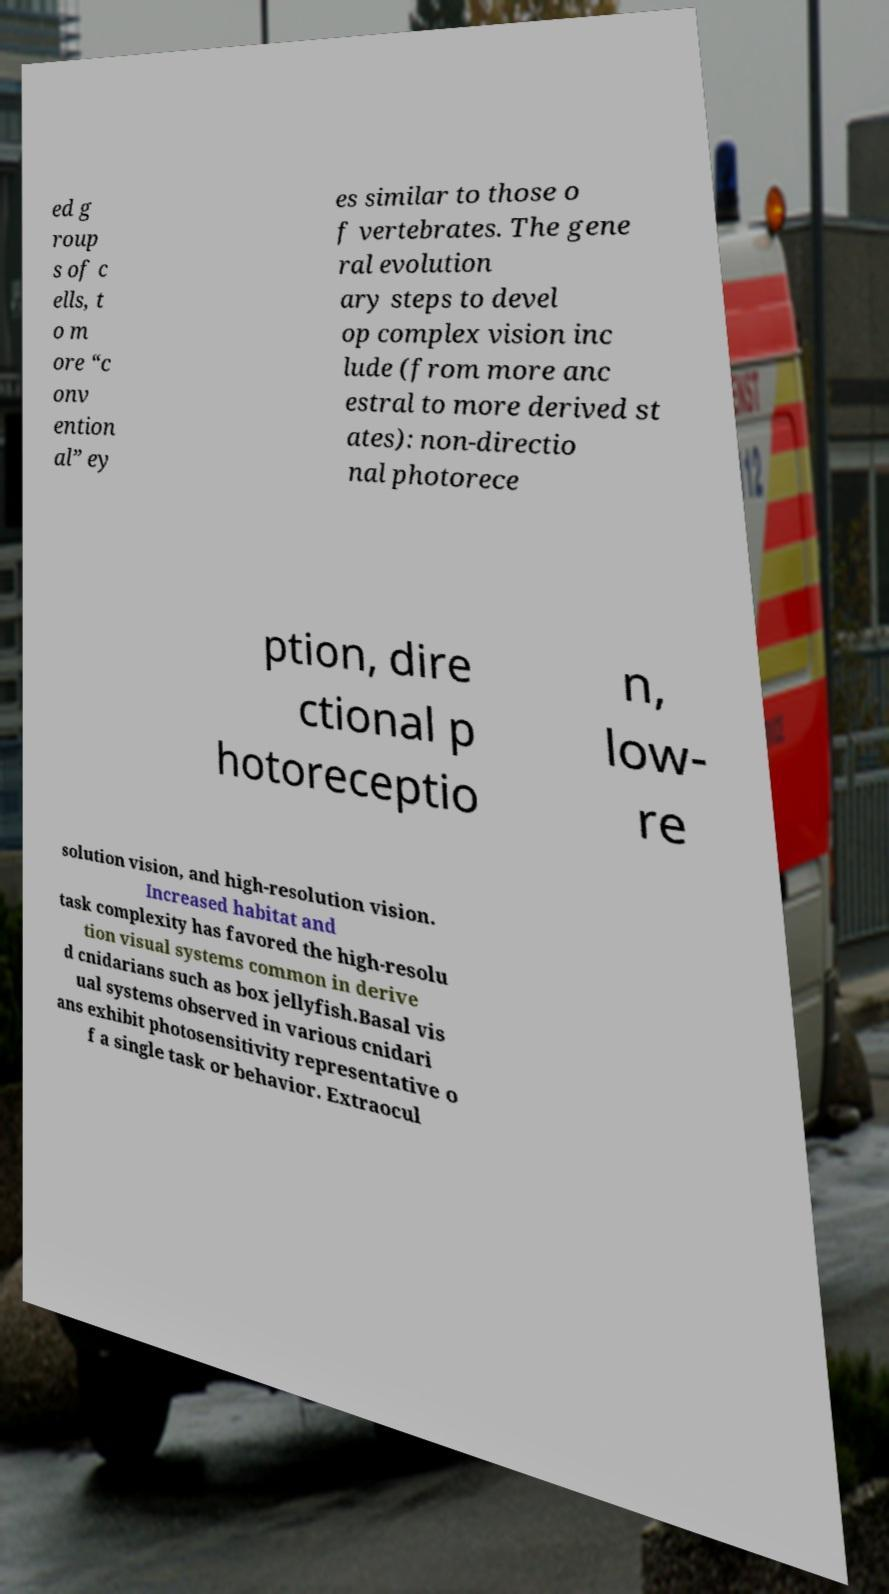Can you read and provide the text displayed in the image?This photo seems to have some interesting text. Can you extract and type it out for me? ed g roup s of c ells, t o m ore “c onv ention al” ey es similar to those o f vertebrates. The gene ral evolution ary steps to devel op complex vision inc lude (from more anc estral to more derived st ates): non-directio nal photorece ption, dire ctional p hotoreceptio n, low- re solution vision, and high-resolution vision. Increased habitat and task complexity has favored the high-resolu tion visual systems common in derive d cnidarians such as box jellyfish.Basal vis ual systems observed in various cnidari ans exhibit photosensitivity representative o f a single task or behavior. Extraocul 